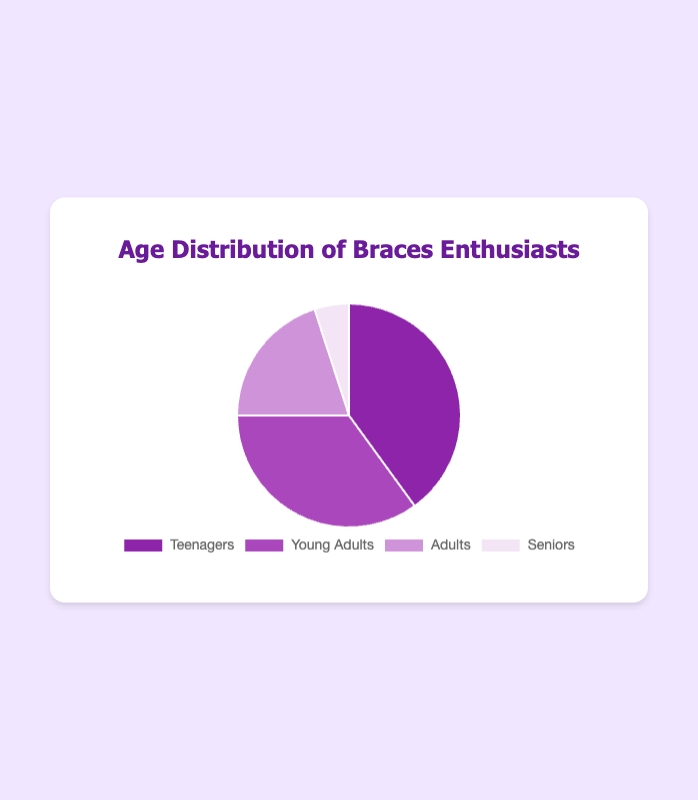How many age groups are represented in the pie chart? There are four distinct segments in the pie chart, each representing a different age group.
Answer: 4 Which age group has the largest percentage of followers seeking braces information? The segment labelled "Teenagers" occupies the largest portion of the pie chart at 40%.
Answer: Teenagers How much larger is the percentage of Young Adults compared to Seniors? Subtract the percentage of Seniors (5%) from the percentage of Young Adults (35%). 35% - 5% = 30%.
Answer: 30% What is the combined percentage of Teenagers and Adults? Add the percentages of Teenagers (40%) and Adults (20%). 40% + 20% = 60%.
Answer: 60% Which color represents the Seniors age group in the pie chart? The segment for Seniors is the lightest shade, identified visually as light purple.
Answer: light purple Is the percentage of Adults greater than or equal to the percentage of Seniors? Compare the segment for Adults (20%) with that of Seniors (5%). 20% is greater than 5%.
Answer: Yes What is the average percentage of the four age groups? Sum the percentages of all age groups and divide by the number of groups. (40% + 35% + 20% + 5%) / 4 = 25%.
Answer: 25% By how much does the percentage of Teenagers exceed the percentage of Adults? Subtract the percentage of Adults (20%) from the percentage of Teenagers (40%). 40% - 20% = 20%.
Answer: 20% What is the median percentage value of the age groups? Arrange the percentages (40%, 35%, 20%, 5%) in ascending order (5%, 20%, 35%, 40%). The median is the average of the two middle values: (20% + 35%) / 2 = 27.5%.
Answer: 27.5% Which two age groups combined have the smallest percentage? Combine the percentages of Seniors (5%) and Adults (20%). 5% + 20% = 25%, which is less than the combination of any other two groups.
Answer: Seniors and Adults 